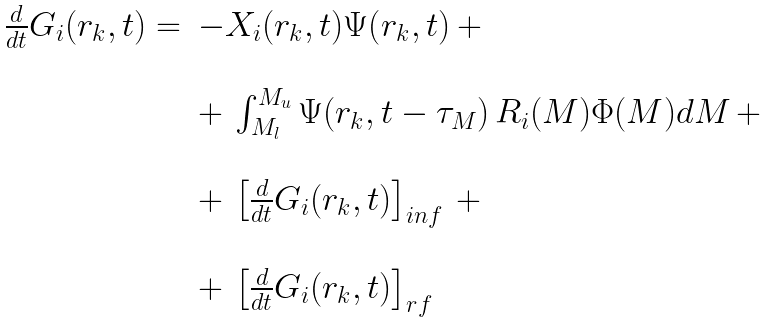Convert formula to latex. <formula><loc_0><loc_0><loc_500><loc_500>\begin{array} { l l } \frac { d } { d t } G _ { i } ( r _ { k } , t ) = & - X _ { i } ( r _ { k } , t ) \Psi ( r _ { k } , t ) \, + \\ & \\ & + \, \int _ { M _ { l } } ^ { M _ { u } } \Psi ( r _ { k } , t - \tau _ { M } ) \, R _ { i } ( M ) \Phi ( M ) d M \, + \\ & \\ & + \, \left [ \frac { d } { d t } G _ { i } ( r _ { k } , t ) \right ] _ { i n f } \, + \, \\ & \\ & + \, \left [ \frac { d } { d t } G _ { i } ( r _ { k } , t ) \right ] _ { r f } \end{array}</formula> 